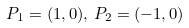Convert formula to latex. <formula><loc_0><loc_0><loc_500><loc_500>P _ { 1 } = ( 1 , 0 ) , \, P _ { 2 } = ( - 1 , 0 )</formula> 